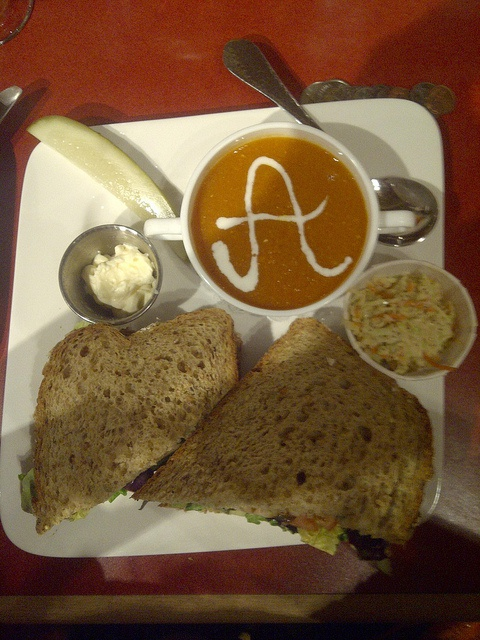Describe the objects in this image and their specific colors. I can see dining table in maroon, olive, black, and tan tones, sandwich in maroon, olive, and black tones, cup in maroon, olive, and tan tones, bowl in maroon, olive, and gray tones, and bowl in maroon, khaki, tan, gray, and olive tones in this image. 